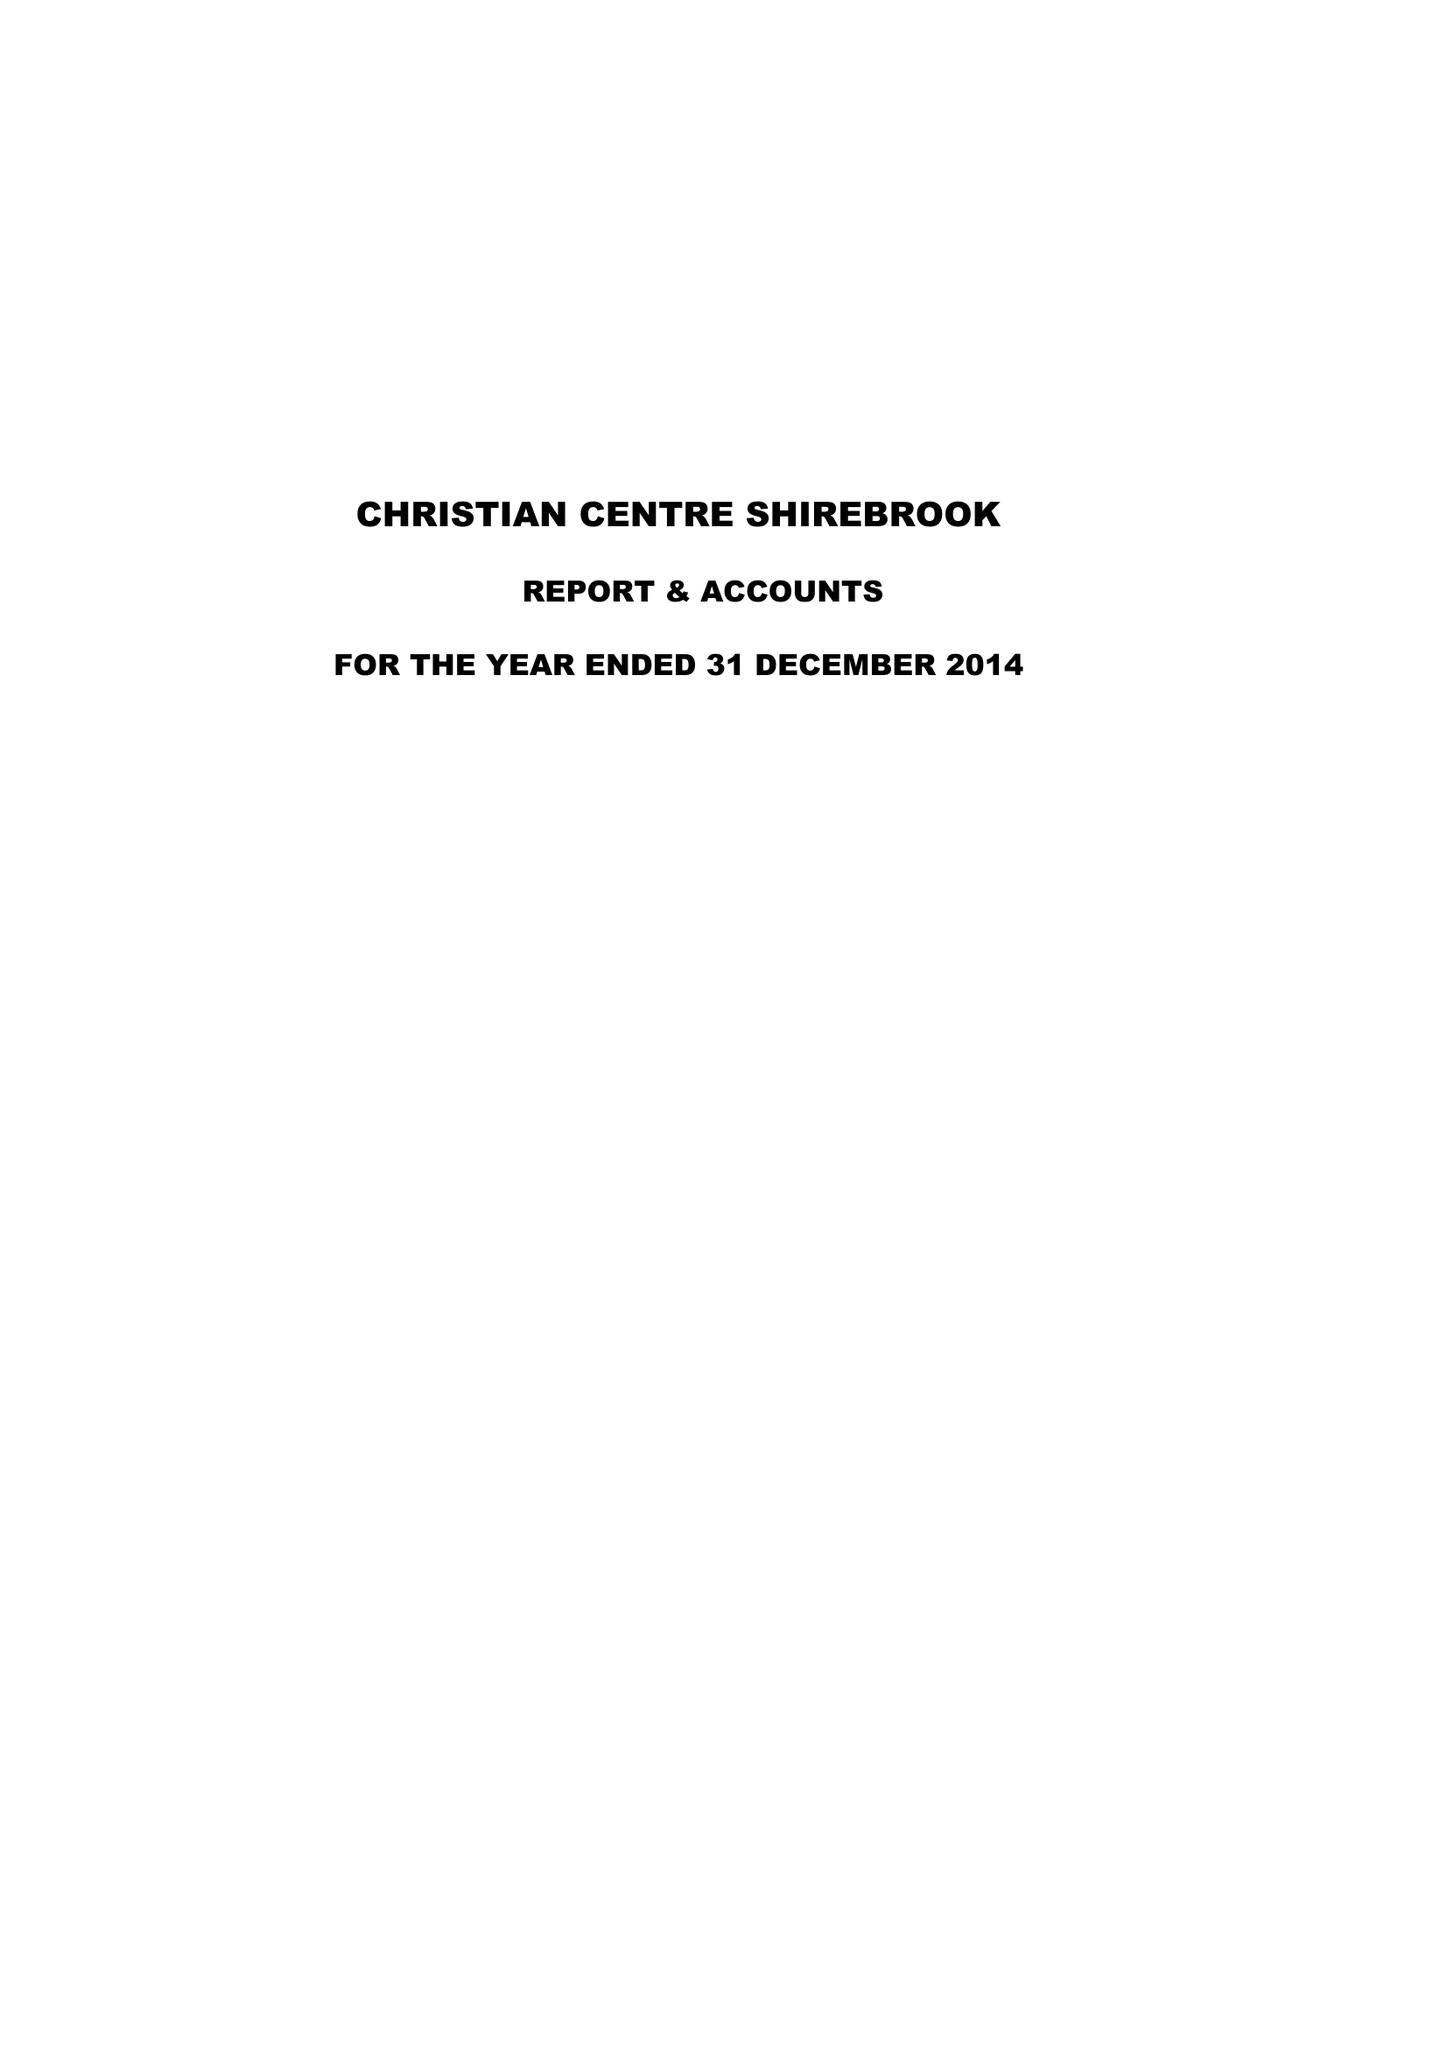What is the value for the address__postcode?
Answer the question using a single word or phrase. NG20 8DG 